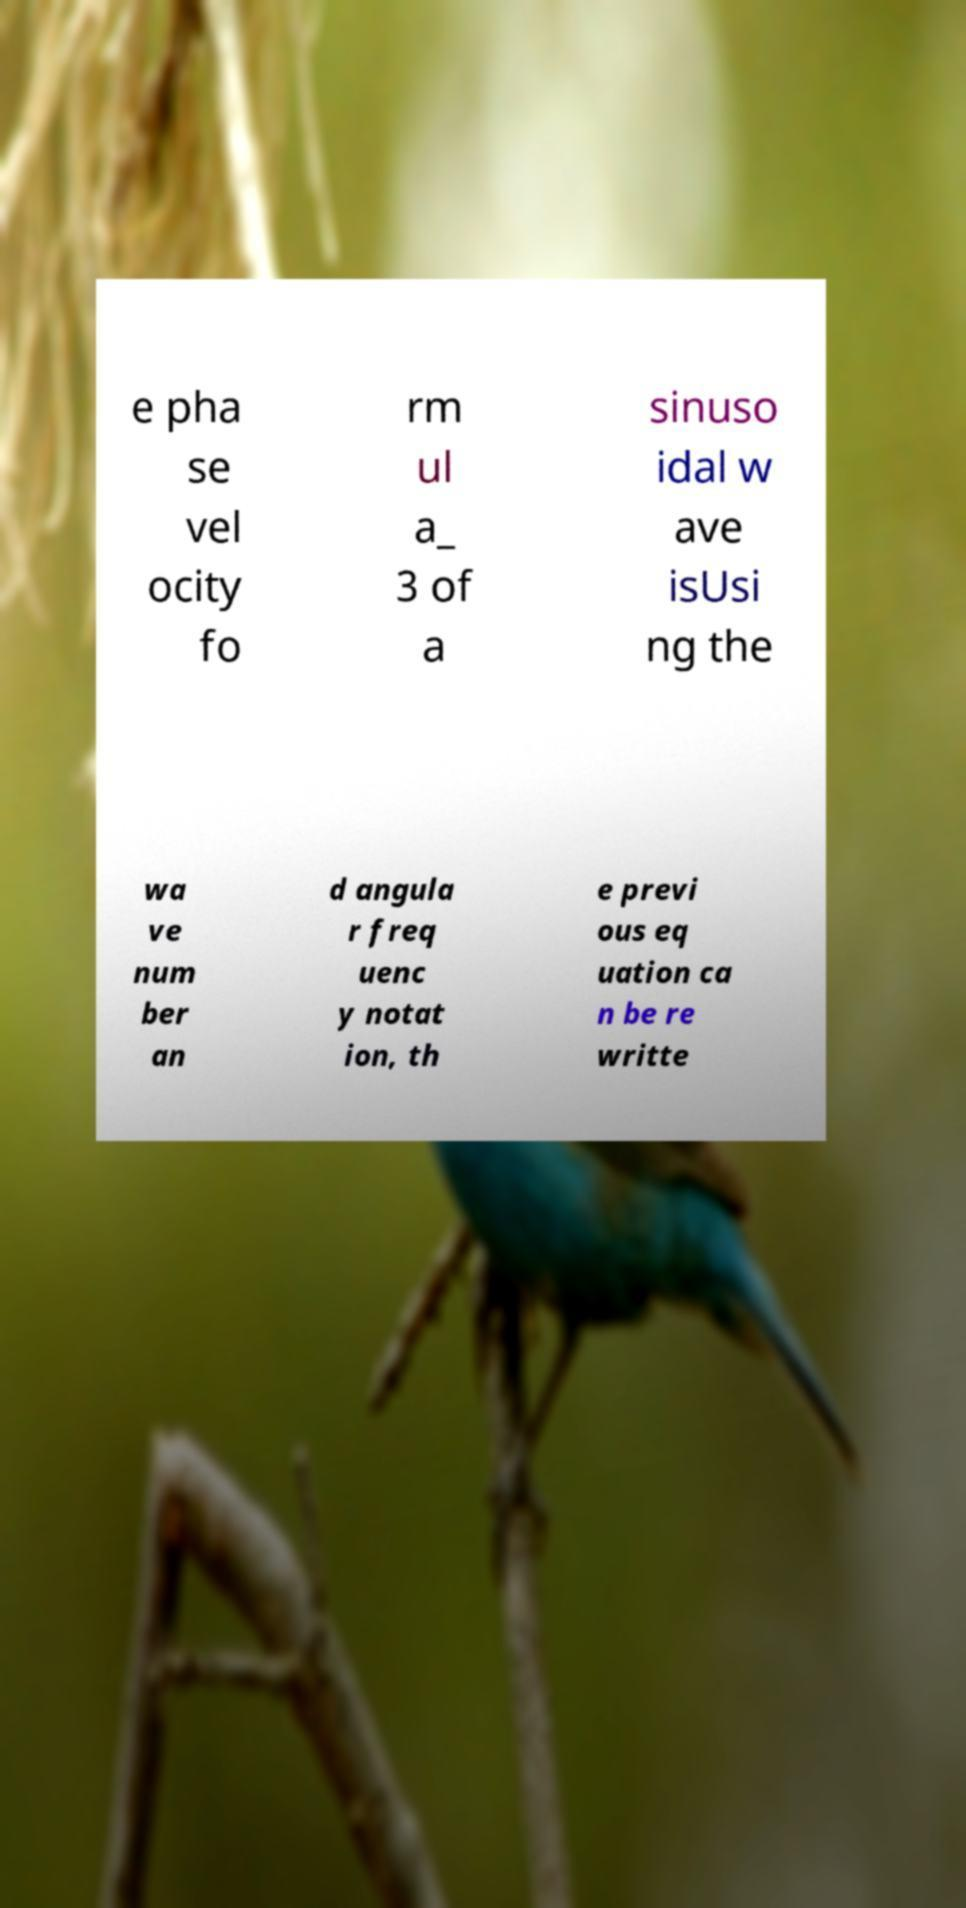Can you read and provide the text displayed in the image?This photo seems to have some interesting text. Can you extract and type it out for me? e pha se vel ocity fo rm ul a_ 3 of a sinuso idal w ave isUsi ng the wa ve num ber an d angula r freq uenc y notat ion, th e previ ous eq uation ca n be re writte 